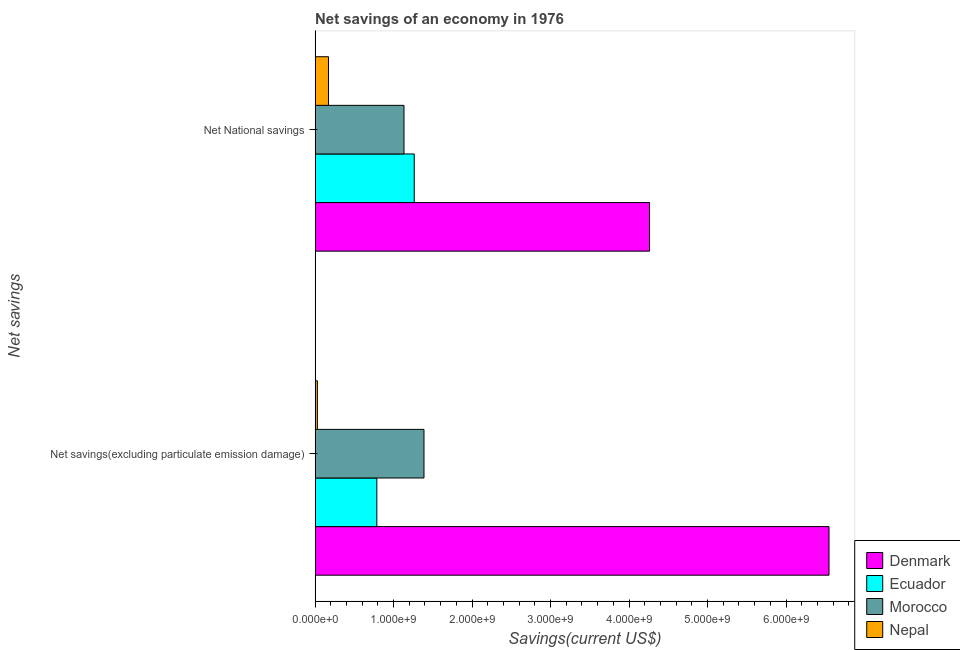How many different coloured bars are there?
Your answer should be very brief. 4. How many groups of bars are there?
Keep it short and to the point. 2. Are the number of bars on each tick of the Y-axis equal?
Ensure brevity in your answer.  Yes. What is the label of the 1st group of bars from the top?
Offer a very short reply. Net National savings. What is the net national savings in Nepal?
Provide a succinct answer. 1.71e+08. Across all countries, what is the maximum net national savings?
Your answer should be compact. 4.26e+09. Across all countries, what is the minimum net savings(excluding particulate emission damage)?
Offer a terse response. 2.92e+07. In which country was the net savings(excluding particulate emission damage) maximum?
Your answer should be compact. Denmark. In which country was the net national savings minimum?
Your answer should be very brief. Nepal. What is the total net savings(excluding particulate emission damage) in the graph?
Make the answer very short. 8.75e+09. What is the difference between the net national savings in Morocco and that in Ecuador?
Provide a succinct answer. -1.30e+08. What is the difference between the net national savings in Morocco and the net savings(excluding particulate emission damage) in Ecuador?
Make the answer very short. 3.46e+08. What is the average net savings(excluding particulate emission damage) per country?
Offer a very short reply. 2.19e+09. What is the difference between the net national savings and net savings(excluding particulate emission damage) in Nepal?
Make the answer very short. 1.41e+08. What is the ratio of the net national savings in Ecuador to that in Nepal?
Provide a short and direct response. 7.41. Is the net national savings in Ecuador less than that in Nepal?
Offer a very short reply. No. What does the 3rd bar from the top in Net savings(excluding particulate emission damage) represents?
Provide a short and direct response. Ecuador. What does the 3rd bar from the bottom in Net savings(excluding particulate emission damage) represents?
Make the answer very short. Morocco. How many bars are there?
Your answer should be very brief. 8. How many countries are there in the graph?
Give a very brief answer. 4. What is the difference between two consecutive major ticks on the X-axis?
Offer a very short reply. 1.00e+09. Does the graph contain grids?
Provide a succinct answer. No. Where does the legend appear in the graph?
Your response must be concise. Bottom right. How are the legend labels stacked?
Provide a succinct answer. Vertical. What is the title of the graph?
Your response must be concise. Net savings of an economy in 1976. What is the label or title of the X-axis?
Your response must be concise. Savings(current US$). What is the label or title of the Y-axis?
Your answer should be very brief. Net savings. What is the Savings(current US$) in Denmark in Net savings(excluding particulate emission damage)?
Your answer should be very brief. 6.55e+09. What is the Savings(current US$) in Ecuador in Net savings(excluding particulate emission damage)?
Your answer should be compact. 7.87e+08. What is the Savings(current US$) of Morocco in Net savings(excluding particulate emission damage)?
Offer a terse response. 1.39e+09. What is the Savings(current US$) of Nepal in Net savings(excluding particulate emission damage)?
Keep it short and to the point. 2.92e+07. What is the Savings(current US$) in Denmark in Net National savings?
Provide a short and direct response. 4.26e+09. What is the Savings(current US$) in Ecuador in Net National savings?
Offer a terse response. 1.26e+09. What is the Savings(current US$) of Morocco in Net National savings?
Your answer should be compact. 1.13e+09. What is the Savings(current US$) in Nepal in Net National savings?
Provide a succinct answer. 1.71e+08. Across all Net savings, what is the maximum Savings(current US$) in Denmark?
Keep it short and to the point. 6.55e+09. Across all Net savings, what is the maximum Savings(current US$) in Ecuador?
Ensure brevity in your answer.  1.26e+09. Across all Net savings, what is the maximum Savings(current US$) in Morocco?
Give a very brief answer. 1.39e+09. Across all Net savings, what is the maximum Savings(current US$) in Nepal?
Give a very brief answer. 1.71e+08. Across all Net savings, what is the minimum Savings(current US$) of Denmark?
Ensure brevity in your answer.  4.26e+09. Across all Net savings, what is the minimum Savings(current US$) of Ecuador?
Your answer should be compact. 7.87e+08. Across all Net savings, what is the minimum Savings(current US$) of Morocco?
Ensure brevity in your answer.  1.13e+09. Across all Net savings, what is the minimum Savings(current US$) of Nepal?
Your answer should be compact. 2.92e+07. What is the total Savings(current US$) of Denmark in the graph?
Your answer should be very brief. 1.08e+1. What is the total Savings(current US$) of Ecuador in the graph?
Make the answer very short. 2.05e+09. What is the total Savings(current US$) in Morocco in the graph?
Offer a terse response. 2.52e+09. What is the total Savings(current US$) in Nepal in the graph?
Provide a short and direct response. 2.00e+08. What is the difference between the Savings(current US$) of Denmark in Net savings(excluding particulate emission damage) and that in Net National savings?
Give a very brief answer. 2.29e+09. What is the difference between the Savings(current US$) of Ecuador in Net savings(excluding particulate emission damage) and that in Net National savings?
Offer a very short reply. -4.76e+08. What is the difference between the Savings(current US$) of Morocco in Net savings(excluding particulate emission damage) and that in Net National savings?
Give a very brief answer. 2.55e+08. What is the difference between the Savings(current US$) in Nepal in Net savings(excluding particulate emission damage) and that in Net National savings?
Ensure brevity in your answer.  -1.41e+08. What is the difference between the Savings(current US$) of Denmark in Net savings(excluding particulate emission damage) and the Savings(current US$) of Ecuador in Net National savings?
Ensure brevity in your answer.  5.28e+09. What is the difference between the Savings(current US$) in Denmark in Net savings(excluding particulate emission damage) and the Savings(current US$) in Morocco in Net National savings?
Offer a very short reply. 5.41e+09. What is the difference between the Savings(current US$) in Denmark in Net savings(excluding particulate emission damage) and the Savings(current US$) in Nepal in Net National savings?
Your answer should be compact. 6.38e+09. What is the difference between the Savings(current US$) of Ecuador in Net savings(excluding particulate emission damage) and the Savings(current US$) of Morocco in Net National savings?
Offer a very short reply. -3.46e+08. What is the difference between the Savings(current US$) of Ecuador in Net savings(excluding particulate emission damage) and the Savings(current US$) of Nepal in Net National savings?
Provide a short and direct response. 6.16e+08. What is the difference between the Savings(current US$) of Morocco in Net savings(excluding particulate emission damage) and the Savings(current US$) of Nepal in Net National savings?
Ensure brevity in your answer.  1.22e+09. What is the average Savings(current US$) in Denmark per Net savings?
Offer a terse response. 5.40e+09. What is the average Savings(current US$) of Ecuador per Net savings?
Make the answer very short. 1.02e+09. What is the average Savings(current US$) in Morocco per Net savings?
Provide a short and direct response. 1.26e+09. What is the average Savings(current US$) of Nepal per Net savings?
Make the answer very short. 9.99e+07. What is the difference between the Savings(current US$) in Denmark and Savings(current US$) in Ecuador in Net savings(excluding particulate emission damage)?
Your answer should be compact. 5.76e+09. What is the difference between the Savings(current US$) in Denmark and Savings(current US$) in Morocco in Net savings(excluding particulate emission damage)?
Make the answer very short. 5.16e+09. What is the difference between the Savings(current US$) in Denmark and Savings(current US$) in Nepal in Net savings(excluding particulate emission damage)?
Ensure brevity in your answer.  6.52e+09. What is the difference between the Savings(current US$) in Ecuador and Savings(current US$) in Morocco in Net savings(excluding particulate emission damage)?
Offer a terse response. -6.01e+08. What is the difference between the Savings(current US$) in Ecuador and Savings(current US$) in Nepal in Net savings(excluding particulate emission damage)?
Ensure brevity in your answer.  7.57e+08. What is the difference between the Savings(current US$) of Morocco and Savings(current US$) of Nepal in Net savings(excluding particulate emission damage)?
Keep it short and to the point. 1.36e+09. What is the difference between the Savings(current US$) in Denmark and Savings(current US$) in Ecuador in Net National savings?
Make the answer very short. 3.00e+09. What is the difference between the Savings(current US$) in Denmark and Savings(current US$) in Morocco in Net National savings?
Offer a very short reply. 3.13e+09. What is the difference between the Savings(current US$) in Denmark and Savings(current US$) in Nepal in Net National savings?
Provide a succinct answer. 4.09e+09. What is the difference between the Savings(current US$) in Ecuador and Savings(current US$) in Morocco in Net National savings?
Keep it short and to the point. 1.30e+08. What is the difference between the Savings(current US$) in Ecuador and Savings(current US$) in Nepal in Net National savings?
Your answer should be compact. 1.09e+09. What is the difference between the Savings(current US$) in Morocco and Savings(current US$) in Nepal in Net National savings?
Your answer should be very brief. 9.62e+08. What is the ratio of the Savings(current US$) of Denmark in Net savings(excluding particulate emission damage) to that in Net National savings?
Give a very brief answer. 1.54. What is the ratio of the Savings(current US$) in Ecuador in Net savings(excluding particulate emission damage) to that in Net National savings?
Give a very brief answer. 0.62. What is the ratio of the Savings(current US$) in Morocco in Net savings(excluding particulate emission damage) to that in Net National savings?
Offer a terse response. 1.22. What is the ratio of the Savings(current US$) in Nepal in Net savings(excluding particulate emission damage) to that in Net National savings?
Ensure brevity in your answer.  0.17. What is the difference between the highest and the second highest Savings(current US$) of Denmark?
Provide a succinct answer. 2.29e+09. What is the difference between the highest and the second highest Savings(current US$) in Ecuador?
Provide a succinct answer. 4.76e+08. What is the difference between the highest and the second highest Savings(current US$) of Morocco?
Offer a terse response. 2.55e+08. What is the difference between the highest and the second highest Savings(current US$) of Nepal?
Offer a terse response. 1.41e+08. What is the difference between the highest and the lowest Savings(current US$) in Denmark?
Keep it short and to the point. 2.29e+09. What is the difference between the highest and the lowest Savings(current US$) in Ecuador?
Offer a terse response. 4.76e+08. What is the difference between the highest and the lowest Savings(current US$) of Morocco?
Keep it short and to the point. 2.55e+08. What is the difference between the highest and the lowest Savings(current US$) in Nepal?
Keep it short and to the point. 1.41e+08. 